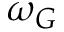<formula> <loc_0><loc_0><loc_500><loc_500>\omega _ { G }</formula> 